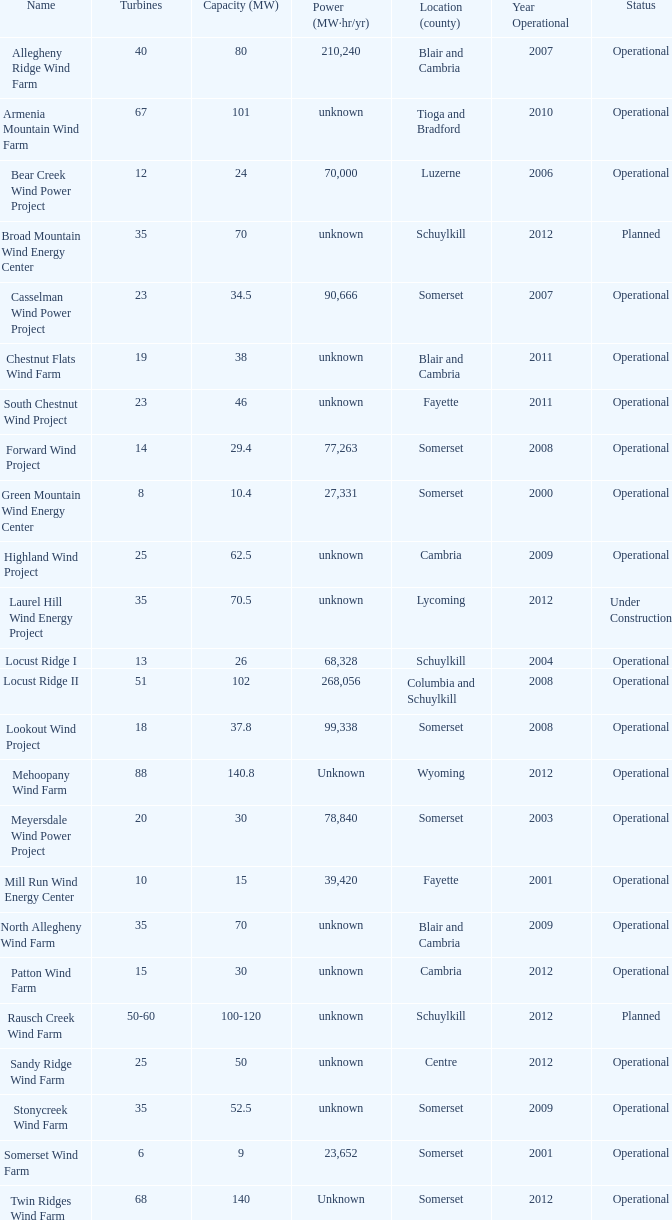What year was Fayette operational at 46? 2011.0. 